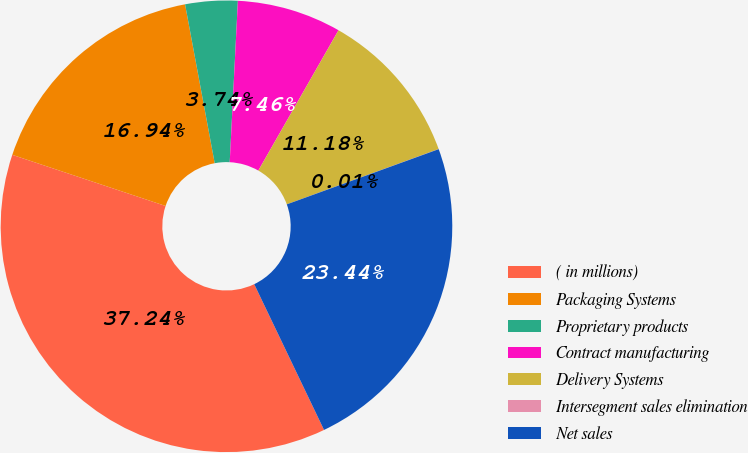<chart> <loc_0><loc_0><loc_500><loc_500><pie_chart><fcel>( in millions)<fcel>Packaging Systems<fcel>Proprietary products<fcel>Contract manufacturing<fcel>Delivery Systems<fcel>Intersegment sales elimination<fcel>Net sales<nl><fcel>37.24%<fcel>16.94%<fcel>3.74%<fcel>7.46%<fcel>11.18%<fcel>0.01%<fcel>23.44%<nl></chart> 